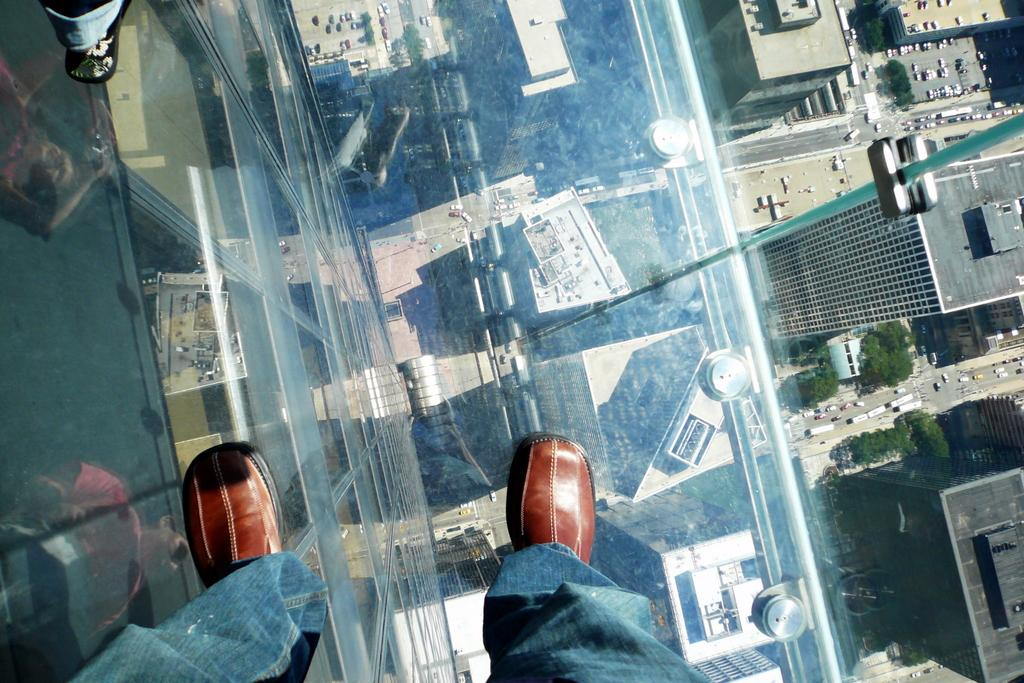What is the main subject of the image? The main subject of the image is the legs of a person visible on a glass platform. What can be seen in the background of the image? In the background of the image, there are trees, buildings, and vehicles on the road. Can you tell me how many flowers are on the shelf in the image? There is no shelf or flowers present in the image. What type of volleyball game is being played in the background of the image? There is no volleyball game present in the image. 